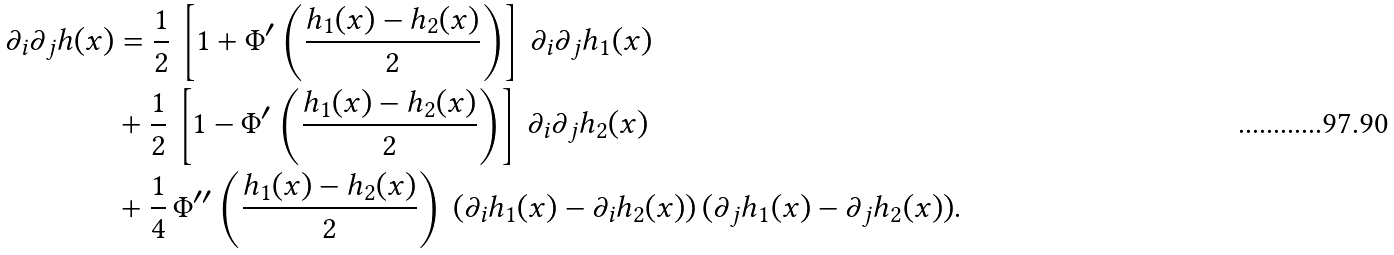<formula> <loc_0><loc_0><loc_500><loc_500>\partial _ { i } \partial _ { j } h ( x ) & = \frac { 1 } { 2 } \, \left [ 1 + \Phi ^ { \prime } \left ( \frac { h _ { 1 } ( x ) - h _ { 2 } ( x ) } { 2 } \right ) \right ] \, \partial _ { i } \partial _ { j } h _ { 1 } ( x ) \\ & + \frac { 1 } { 2 } \, \left [ 1 - \Phi ^ { \prime } \left ( \frac { h _ { 1 } ( x ) - h _ { 2 } ( x ) } { 2 } \right ) \right ] \, \partial _ { i } \partial _ { j } h _ { 2 } ( x ) \\ & + \frac { 1 } { 4 } \, \Phi ^ { \prime \prime } \left ( \frac { h _ { 1 } ( x ) - h _ { 2 } ( x ) } { 2 } \right ) \, ( \partial _ { i } h _ { 1 } ( x ) - \partial _ { i } h _ { 2 } ( x ) ) \, ( \partial _ { j } h _ { 1 } ( x ) - \partial _ { j } h _ { 2 } ( x ) ) .</formula> 